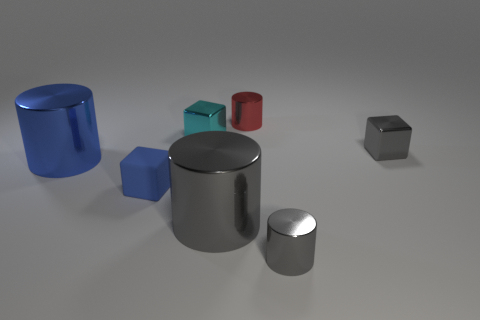Subtract all tiny blue blocks. How many blocks are left? 2 Add 1 large metal spheres. How many objects exist? 8 Subtract all cyan blocks. How many blocks are left? 2 Subtract 3 cubes. How many cubes are left? 0 Subtract all red rubber balls. Subtract all large gray cylinders. How many objects are left? 6 Add 6 small cyan blocks. How many small cyan blocks are left? 7 Add 1 large cylinders. How many large cylinders exist? 3 Subtract 0 red cubes. How many objects are left? 7 Subtract all cylinders. How many objects are left? 3 Subtract all brown cylinders. Subtract all cyan spheres. How many cylinders are left? 4 